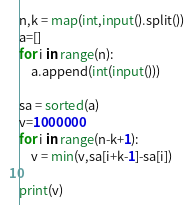<code> <loc_0><loc_0><loc_500><loc_500><_Python_>n,k = map(int,input().split())
a=[]
for i in range(n):
	a.append(int(input()))

sa = sorted(a)
v=1000000
for i in range(n-k+1):
	v = min(v,sa[i+k-1]-sa[i]) 

print(v)</code> 